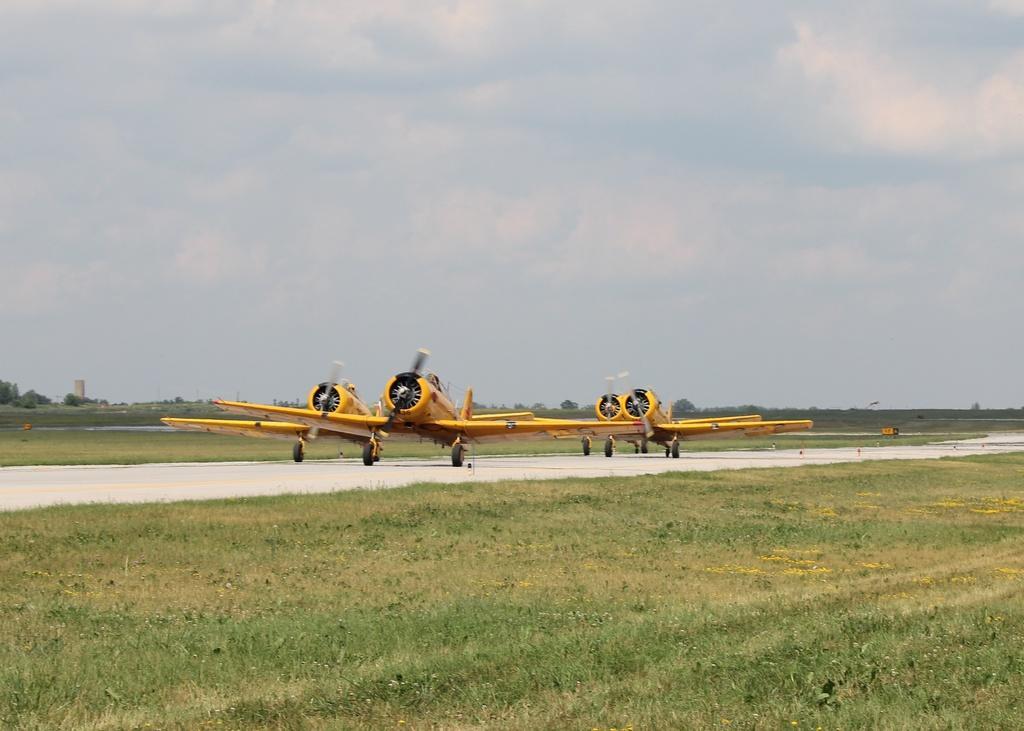Describe this image in one or two sentences. In this image I can see few aircraft's which are yellow in color on the runway. I can see some grass and the runway. In the background I can see few trees, few buildings and the sky. 